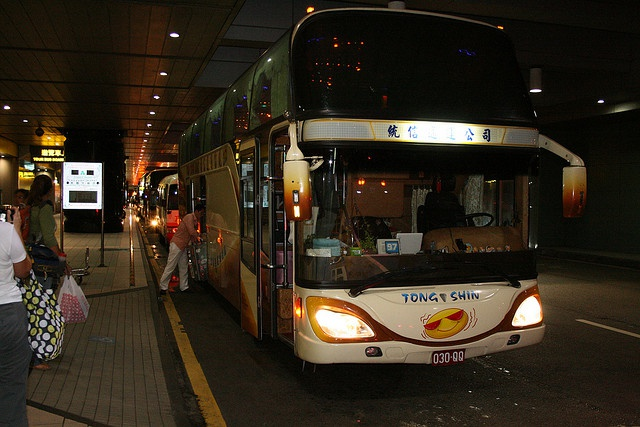Describe the objects in this image and their specific colors. I can see bus in black, maroon, tan, and gray tones, people in black, darkgray, maroon, and gray tones, handbag in black, darkgray, gray, and olive tones, people in black, maroon, and olive tones, and people in black, maroon, and gray tones in this image. 